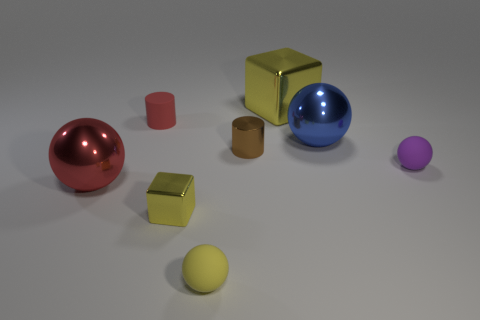Subtract all yellow matte balls. How many balls are left? 3 Subtract all purple spheres. How many spheres are left? 3 Add 1 purple rubber spheres. How many objects exist? 9 Subtract 1 balls. How many balls are left? 3 Subtract 1 purple spheres. How many objects are left? 7 Subtract all cylinders. How many objects are left? 6 Subtract all brown blocks. Subtract all purple spheres. How many blocks are left? 2 Subtract all matte cylinders. Subtract all tiny rubber cylinders. How many objects are left? 6 Add 4 tiny brown objects. How many tiny brown objects are left? 5 Add 5 big objects. How many big objects exist? 8 